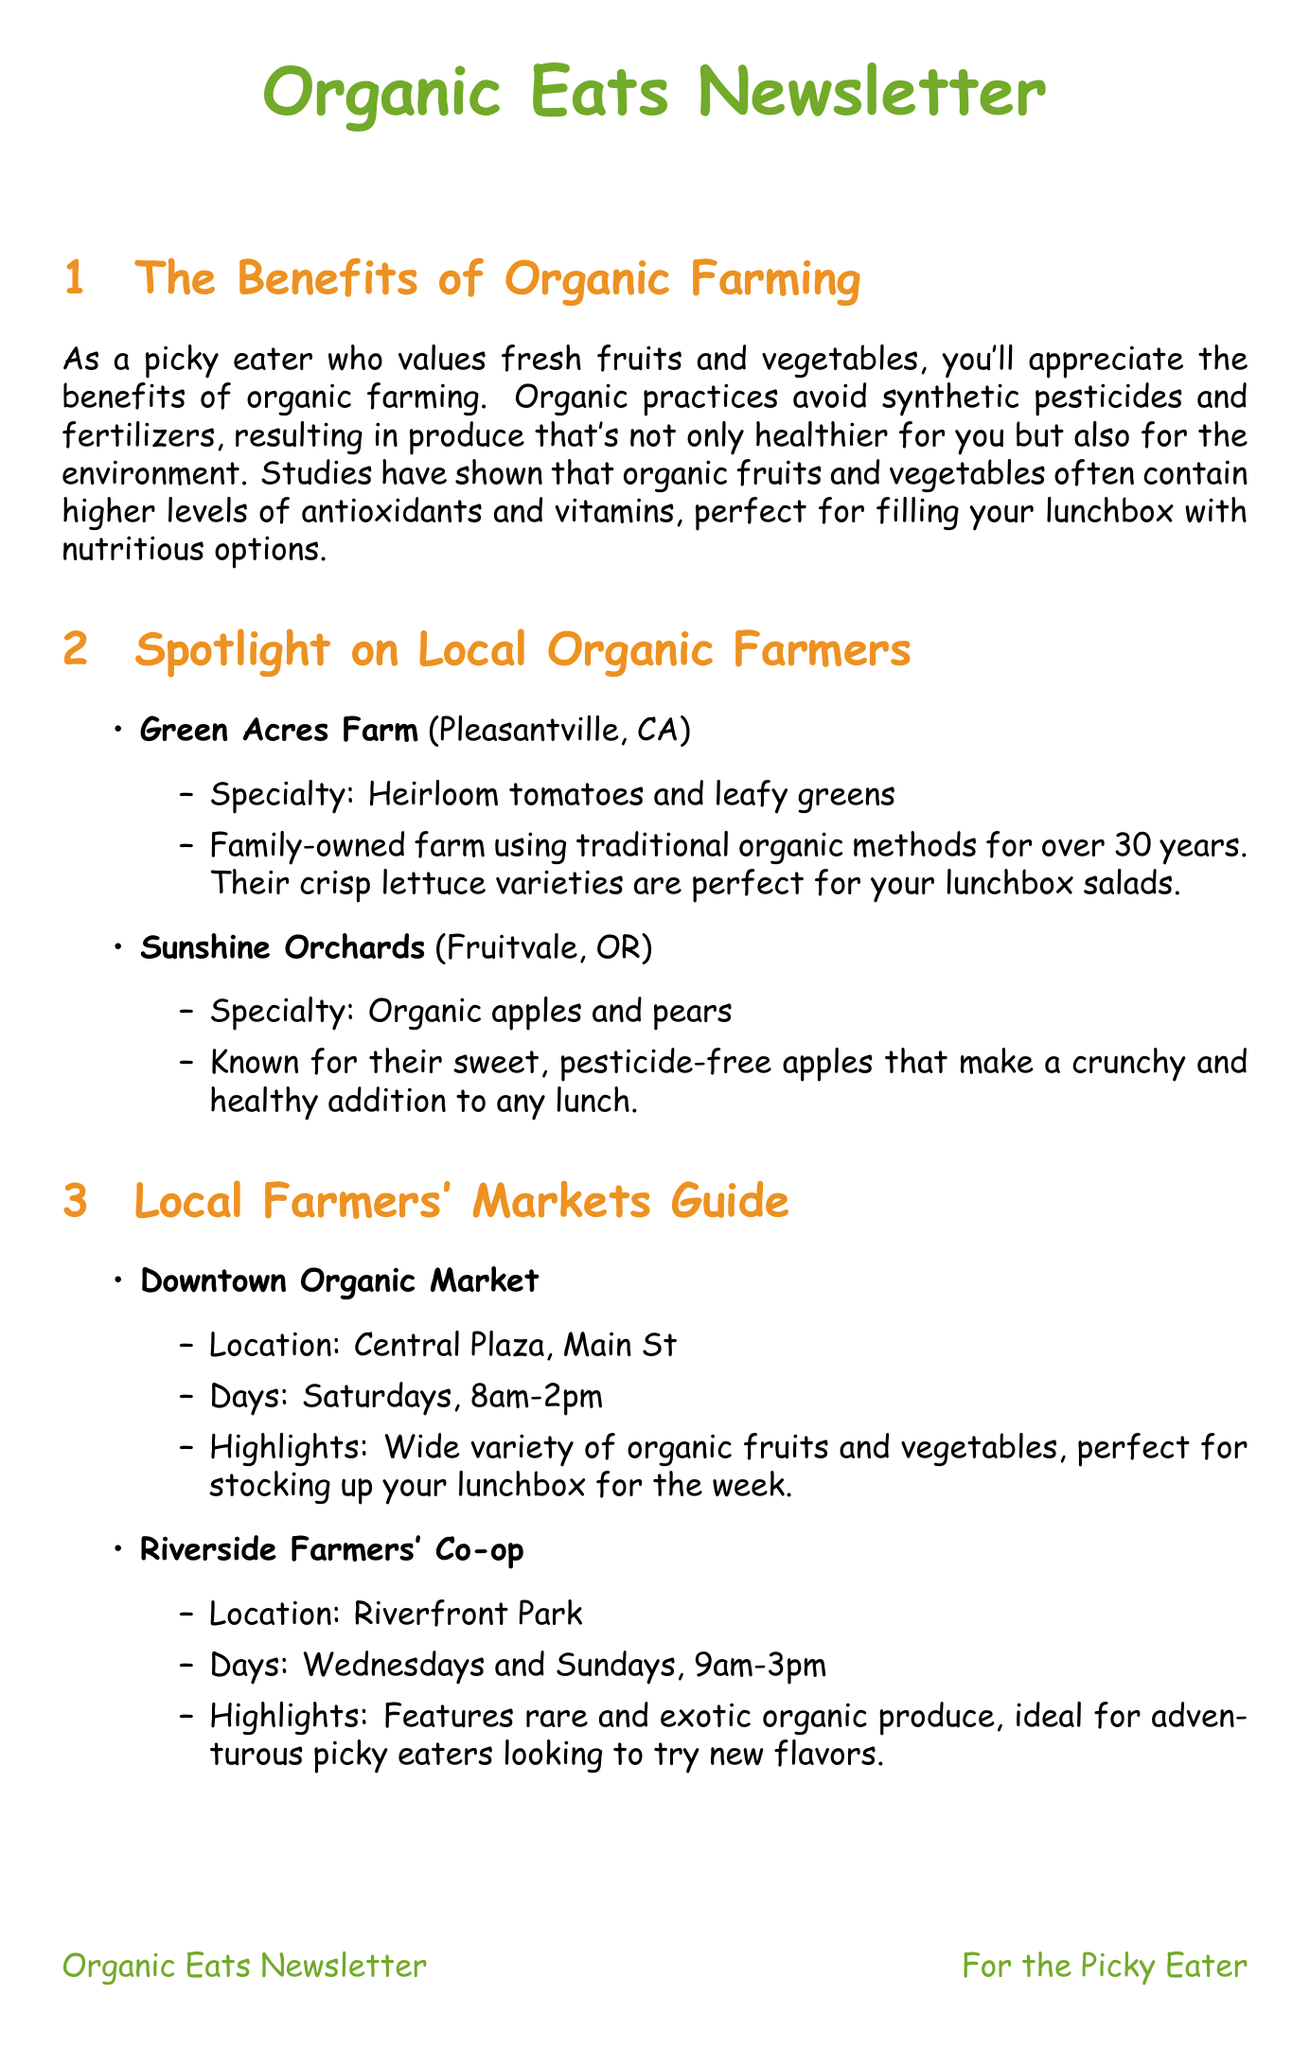What are the specialties of Green Acres Farm? Green Acres Farm specializes in heirloom tomatoes and leafy greens, as provided in the document.
Answer: Heirloom tomatoes and leafy greens When is the Farm-to-Table Cooking Workshop? The document states that the Farm-to-Table Cooking Workshop takes place on October 8, 2023.
Answer: October 8, 2023 What is the location of the Annual Organic Apple Festival? The location of the Annual Organic Apple Festival is given as the Applewood Community Center in the document.
Answer: Applewood Community Center Which farmers' market is open on Sundays? The Riverside Farmers' Co-op is mentioned in the document as being open on Sundays.
Answer: Riverside Farmers' Co-op What is one of the organic lunchbox ideas mentioned in the document? One example from the document is colorful organic vegetable sticks with homemade hummus, as listed in the lunchbox ideas section.
Answer: Colorful organic vegetable sticks with homemade hummus How many days a week does the Downtown Organic Market operate? The Downtown Organic Market operates on Saturdays, meaning it is open 1 day per week, according to the document.
Answer: 1 day What is a highlight of the Riverside Farmers' Co-op? The document mentions that the Riverside Farmers' Co-op features rare and exotic organic produce as a highlight.
Answer: Rare and exotic organic produce How long is the Organic Farming Symposium? The document indicates that the Organic Farming Symposium is a three-day event.
Answer: Three days What type of event is scheduled for November 3-5, 2023? The document states that the event during this time is the Organic Farming Symposium.
Answer: Organic Farming Symposium 